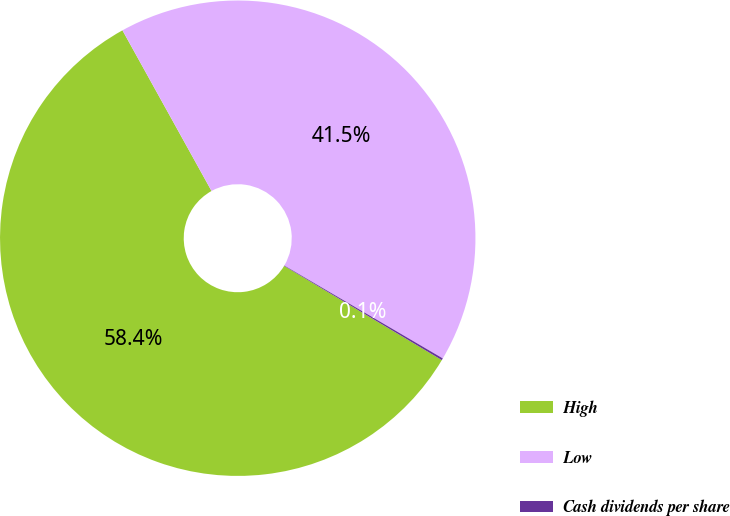<chart> <loc_0><loc_0><loc_500><loc_500><pie_chart><fcel>High<fcel>Low<fcel>Cash dividends per share<nl><fcel>58.38%<fcel>41.5%<fcel>0.13%<nl></chart> 